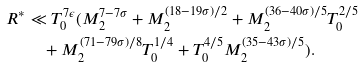Convert formula to latex. <formula><loc_0><loc_0><loc_500><loc_500>R ^ { * } & \ll T _ { 0 } ^ { 7 \epsilon } ( M _ { 2 } ^ { 7 - 7 \sigma } + M _ { 2 } ^ { ( 1 8 - 1 9 \sigma ) / 2 } + M _ { 2 } ^ { ( 3 6 - 4 0 \sigma ) / 5 } T _ { 0 } ^ { 2 / 5 } \\ & \quad + M _ { 2 } ^ { ( 7 1 - 7 9 \sigma ) / 8 } T _ { 0 } ^ { 1 / 4 } + T _ { 0 } ^ { 4 / 5 } M _ { 2 } ^ { ( 3 5 - 4 3 \sigma ) / 5 } ) .</formula> 